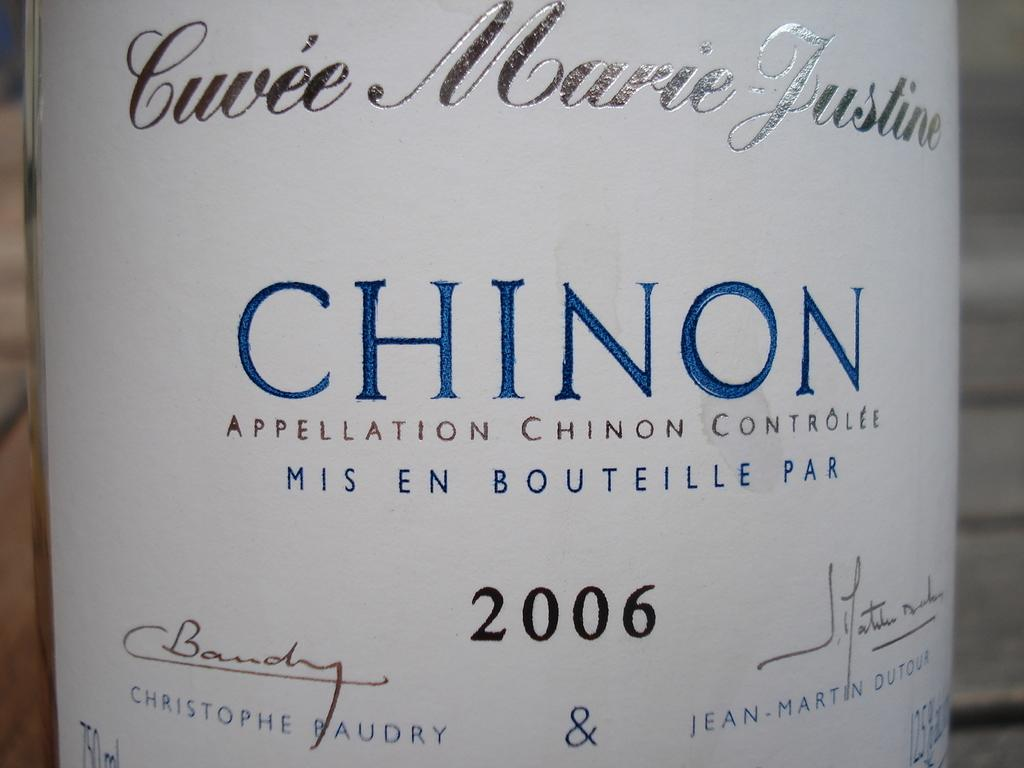<image>
Provide a brief description of the given image. A closeup of a label that says Chinon in blue letters on a white label. 